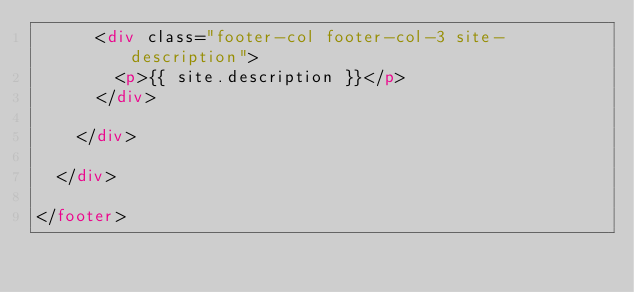Convert code to text. <code><loc_0><loc_0><loc_500><loc_500><_HTML_>      <div class="footer-col footer-col-3 site-description">
        <p>{{ site.description }}</p>
      </div>
      
    </div>

  </div>

</footer>
</code> 